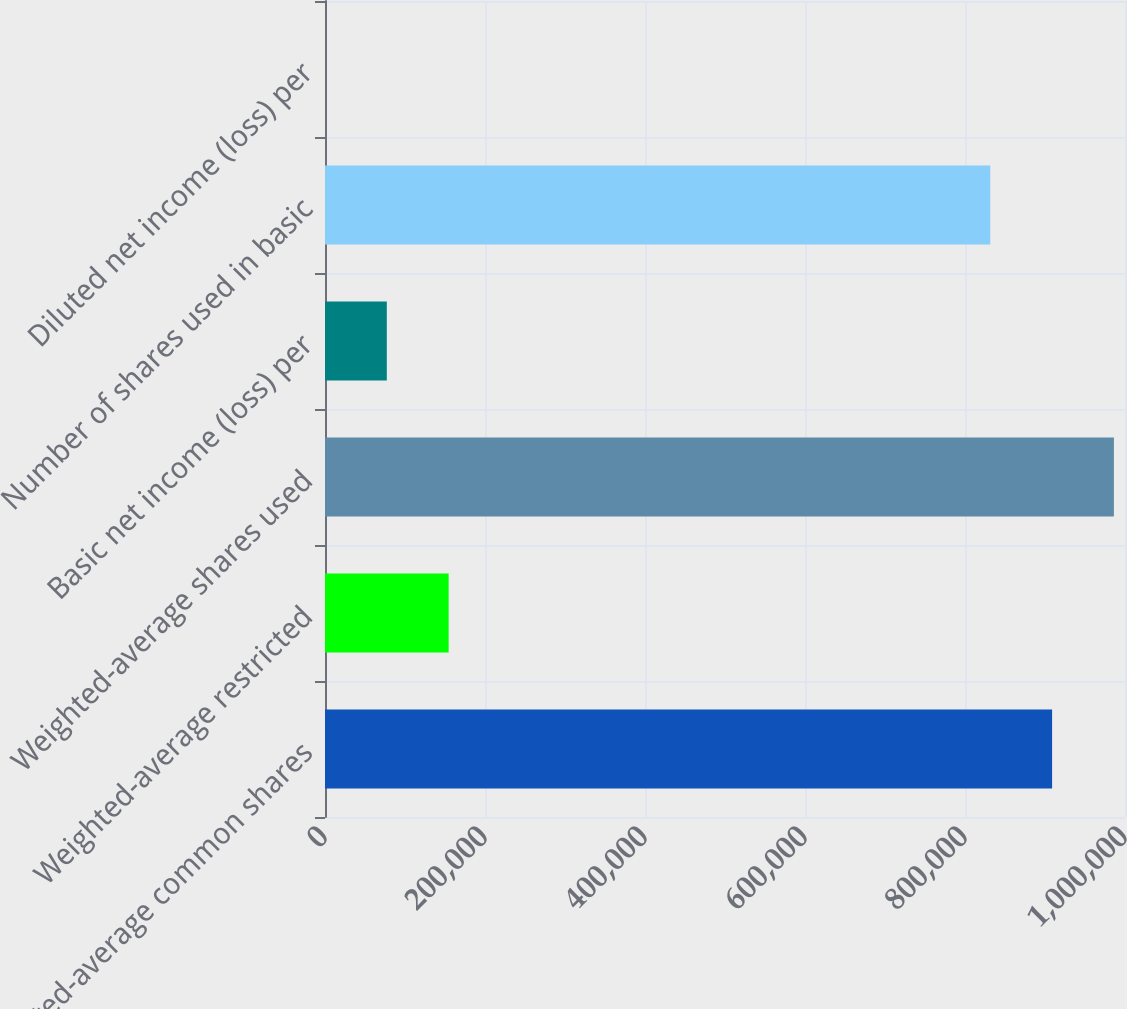Convert chart. <chart><loc_0><loc_0><loc_500><loc_500><bar_chart><fcel>Weighted-average common shares<fcel>Weighted-average restricted<fcel>Weighted-average shares used<fcel>Basic net income (loss) per<fcel>Number of shares used in basic<fcel>Diluted net income (loss) per<nl><fcel>908863<fcel>154538<fcel>986131<fcel>77270<fcel>831594<fcel>1.56<nl></chart> 